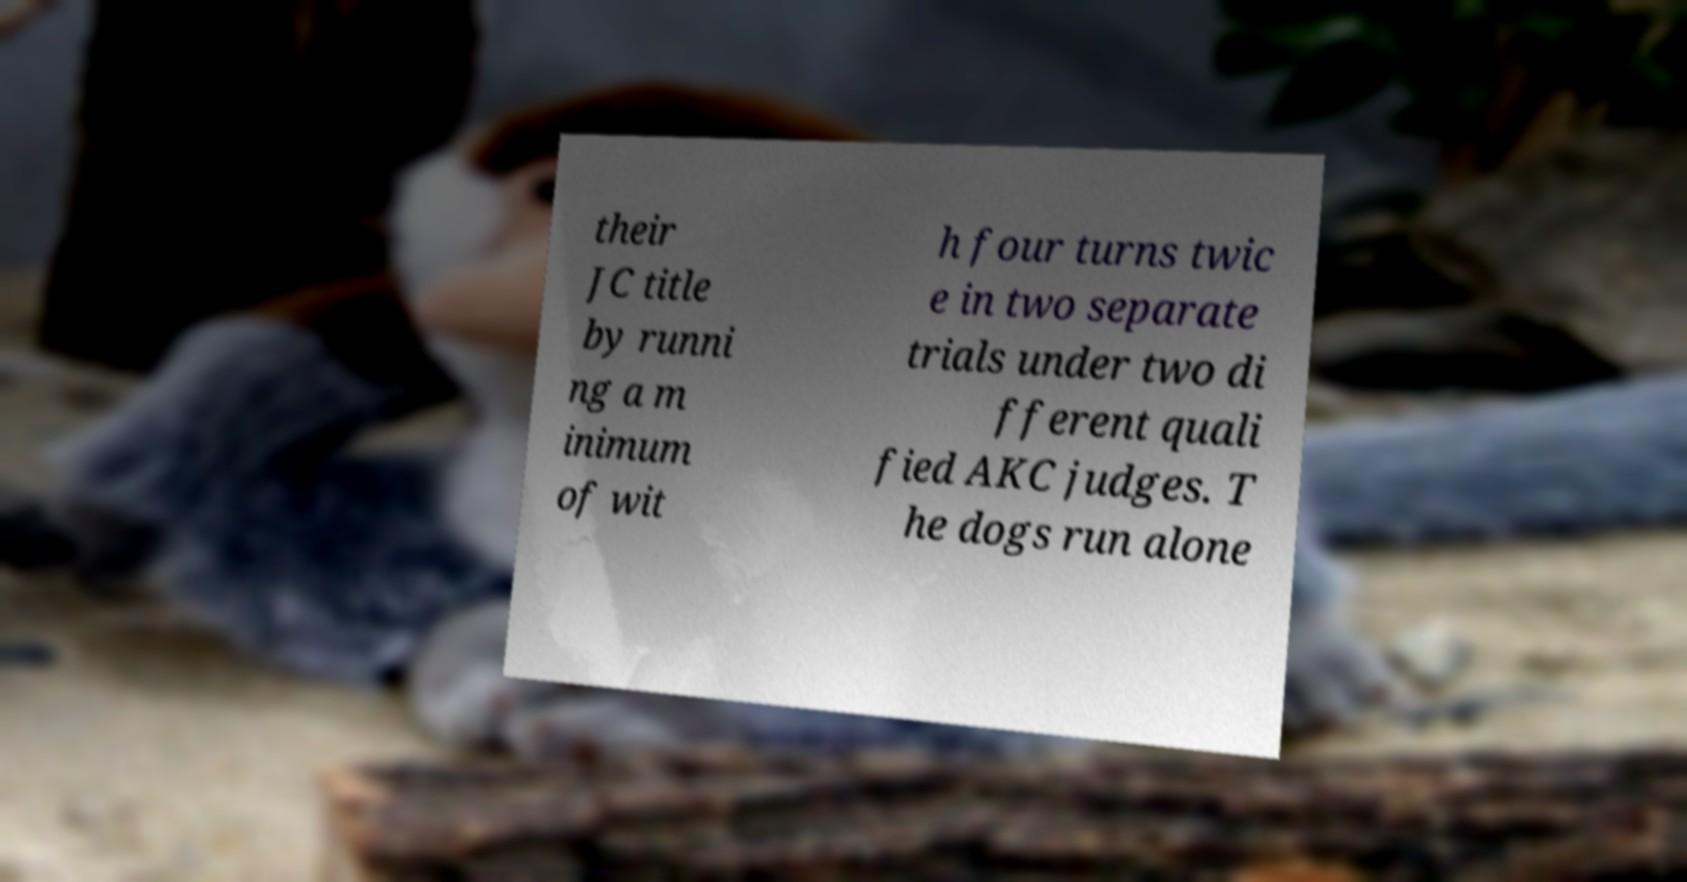Could you extract and type out the text from this image? their JC title by runni ng a m inimum of wit h four turns twic e in two separate trials under two di fferent quali fied AKC judges. T he dogs run alone 